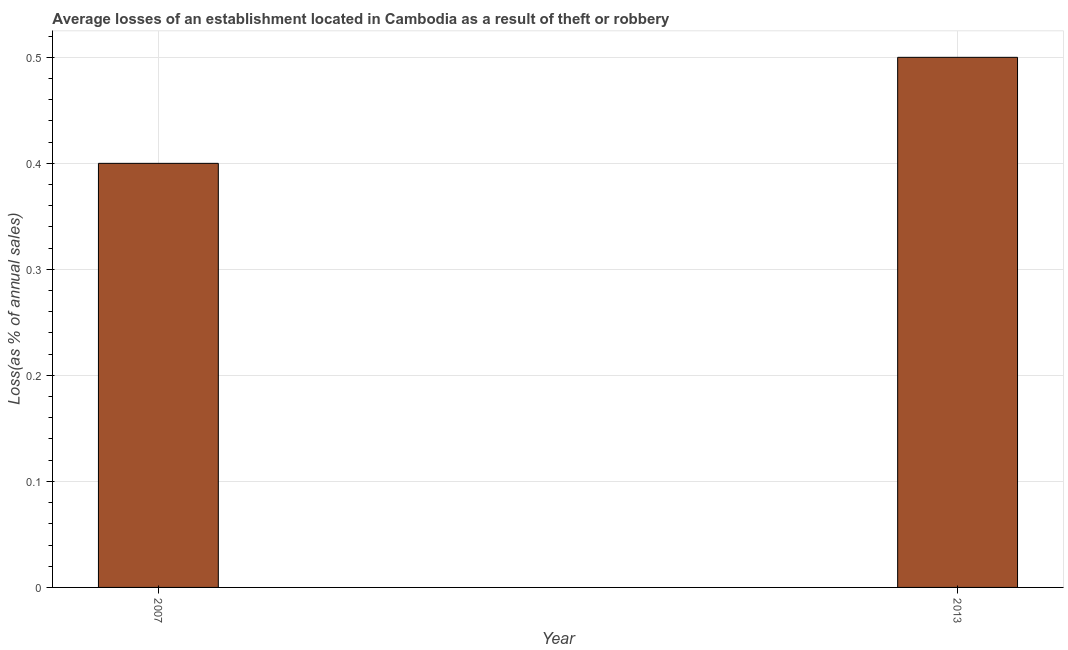Does the graph contain any zero values?
Provide a succinct answer. No. Does the graph contain grids?
Your answer should be very brief. Yes. What is the title of the graph?
Your answer should be very brief. Average losses of an establishment located in Cambodia as a result of theft or robbery. What is the label or title of the Y-axis?
Your answer should be compact. Loss(as % of annual sales). What is the losses due to theft in 2013?
Provide a succinct answer. 0.5. Across all years, what is the maximum losses due to theft?
Provide a short and direct response. 0.5. In which year was the losses due to theft minimum?
Ensure brevity in your answer.  2007. What is the difference between the losses due to theft in 2007 and 2013?
Your answer should be very brief. -0.1. What is the average losses due to theft per year?
Provide a succinct answer. 0.45. What is the median losses due to theft?
Your response must be concise. 0.45. In how many years, is the losses due to theft greater than 0.28 %?
Ensure brevity in your answer.  2. Is the losses due to theft in 2007 less than that in 2013?
Provide a short and direct response. Yes. In how many years, is the losses due to theft greater than the average losses due to theft taken over all years?
Provide a short and direct response. 1. What is the difference between two consecutive major ticks on the Y-axis?
Keep it short and to the point. 0.1. What is the Loss(as % of annual sales) in 2007?
Provide a succinct answer. 0.4. What is the difference between the Loss(as % of annual sales) in 2007 and 2013?
Offer a very short reply. -0.1. What is the ratio of the Loss(as % of annual sales) in 2007 to that in 2013?
Offer a very short reply. 0.8. 